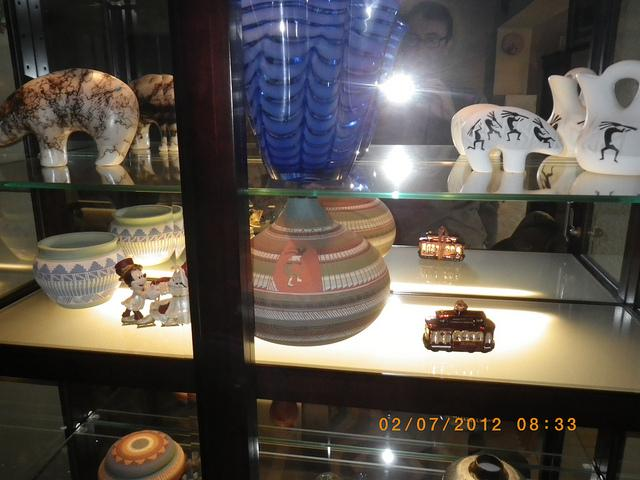What is the mouse's wife's name? minnie 